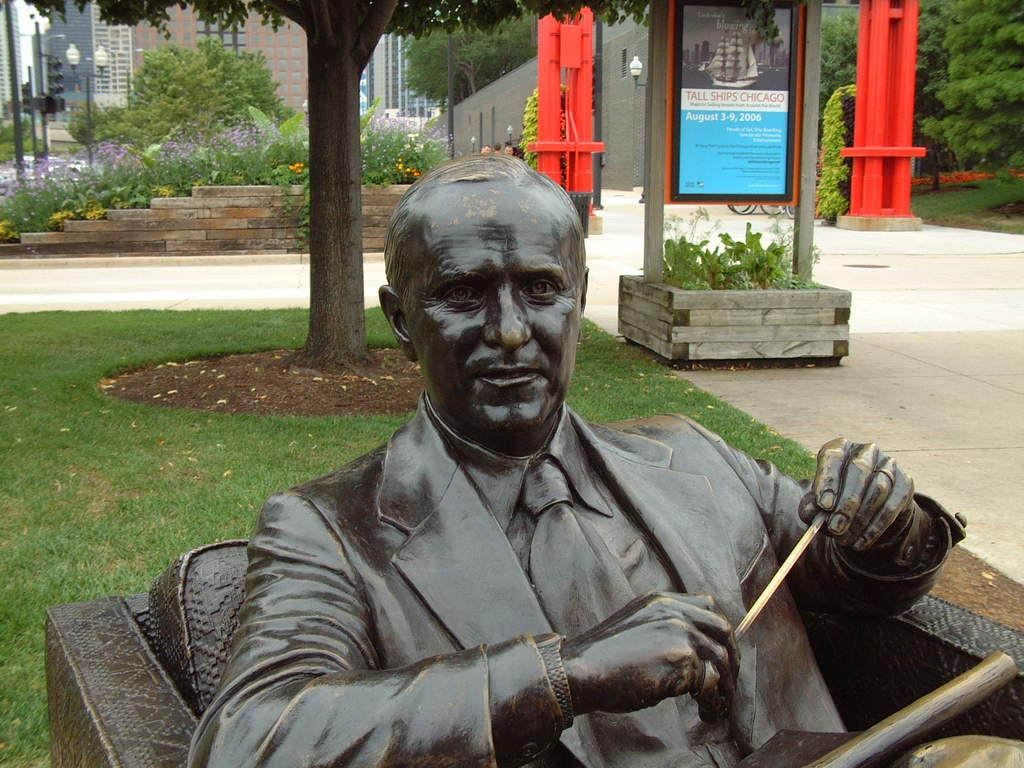What is the main subject of the image? There is a man sculpture in the image. What is located behind the sculpture? There is grass behind the sculpture. What other objects can be seen in the image? There is a board and plants in the image. What can be seen in the background of the image? Buildings, lights on poles, plants, and trees are visible in the background. Can you tell me how the rock is positioned in relation to the ocean in the image? There is no rock or ocean present in the image; it features a man sculpture, grass, a board, plants, buildings, lights on poles, plants, and trees in the background. 